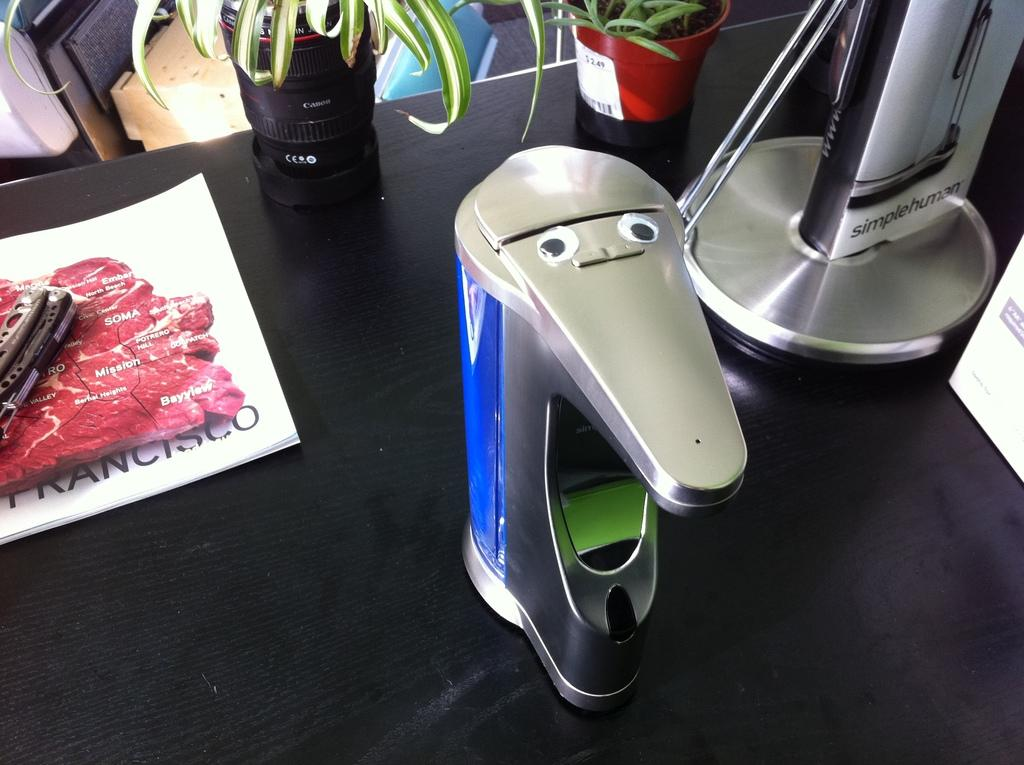<image>
Present a compact description of the photo's key features. On the desk there are many gadgets including one made by the simple human company. 